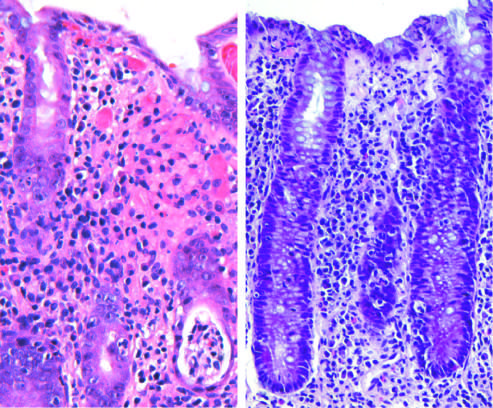what is similar to other acute, self-limited colitides?
Answer the question using a single word or phrase. Enteroinvasive escherichia coli infection 